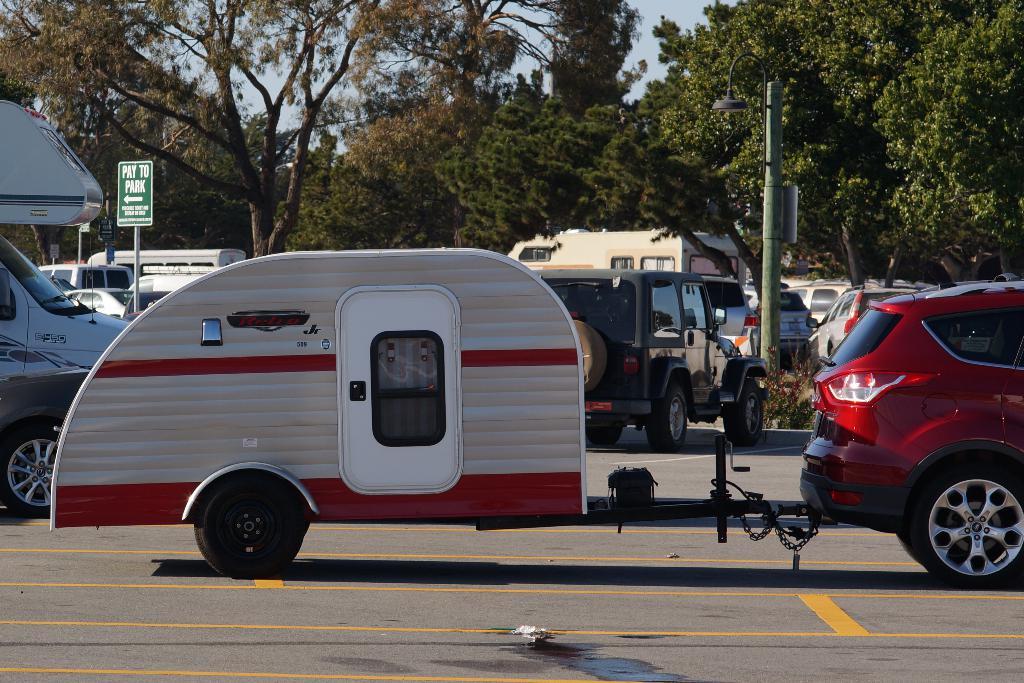Do you have to pay to park here according to the sign?
Keep it short and to the point. Yes. What does the green sign say?
Your answer should be compact. Pay to park. 